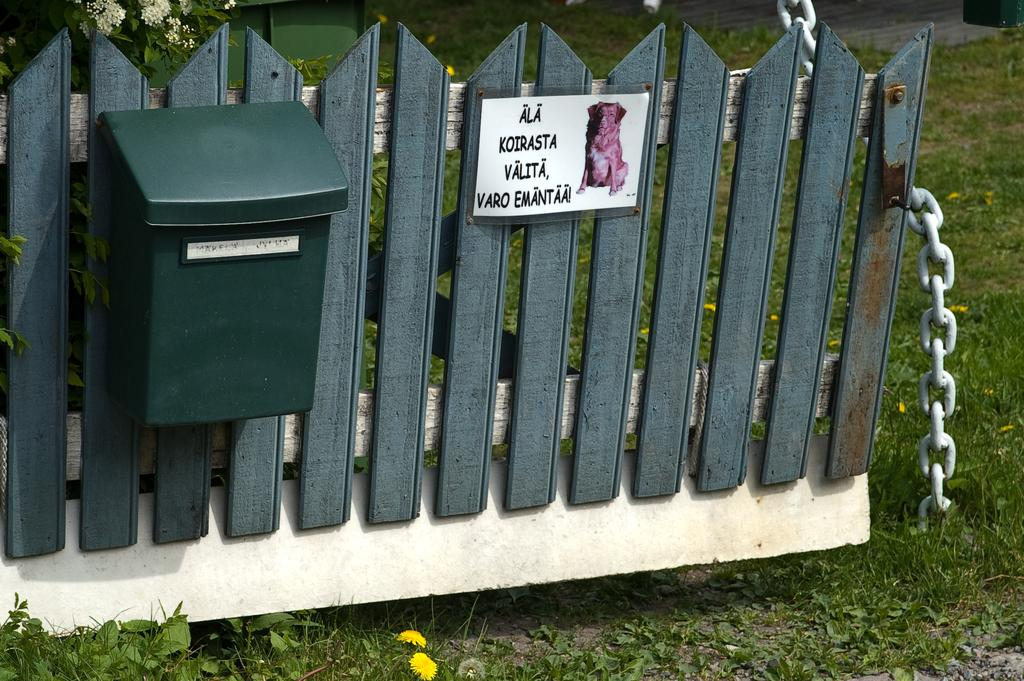What type of structure can be seen in the image? There is a fence in the image. What other objects can be seen in the image? There is a board, a mailbox, and a chain visible in the image. What type of vegetation is present in the image? There is grass, plants, and flowers in the image. What type of vegetable is growing in the image? There are no vegetables present in the image; it features grass, plants, and flowers. Can you tell me how many animals are in the zoo in the image? There is no zoo present in the image, and therefore no animals can be observed. 